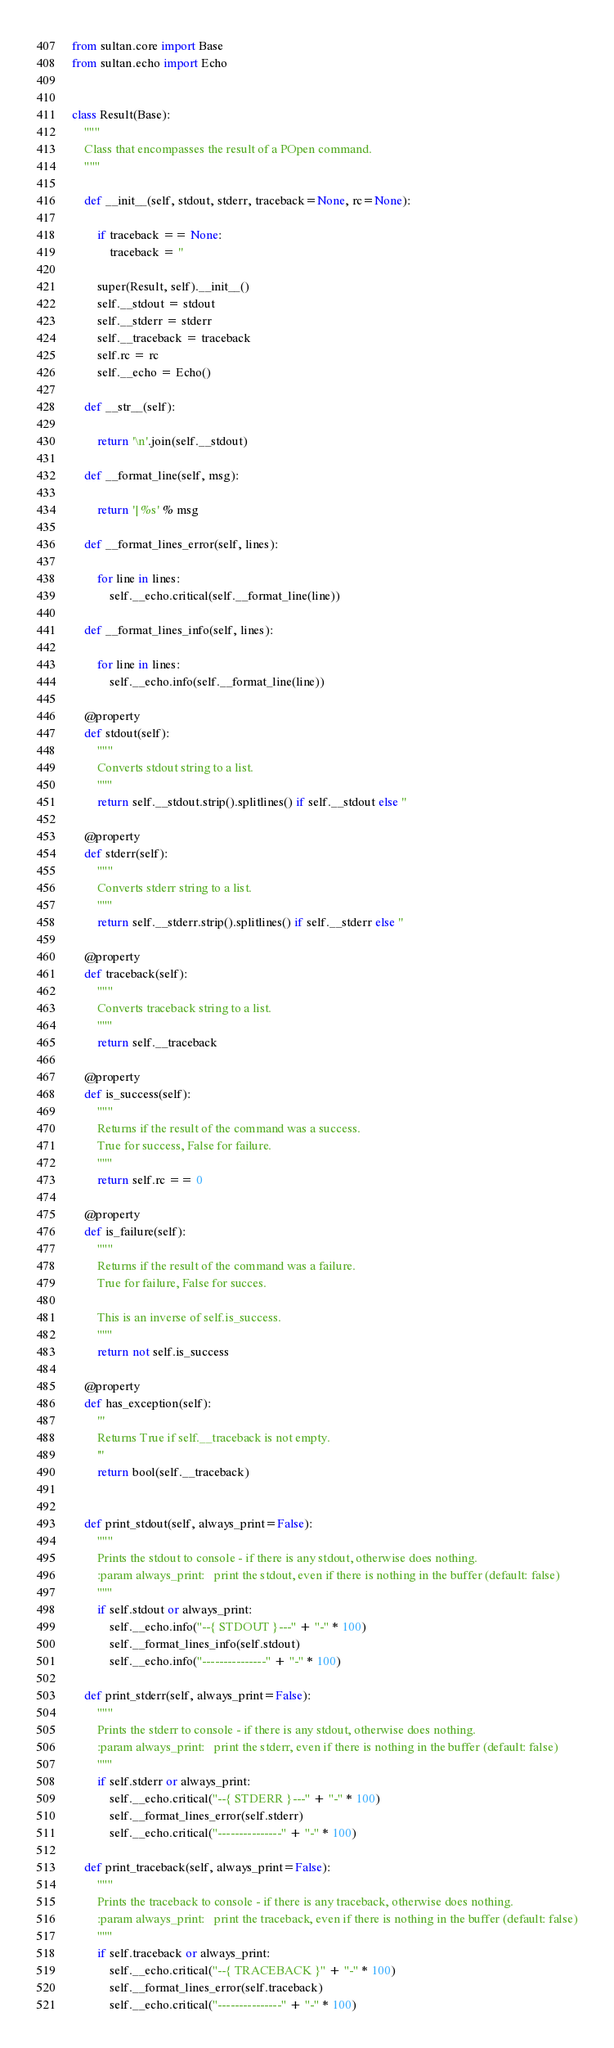Convert code to text. <code><loc_0><loc_0><loc_500><loc_500><_Python_>from sultan.core import Base
from sultan.echo import Echo


class Result(Base):
    """
    Class that encompasses the result of a POpen command.
    """

    def __init__(self, stdout, stderr, traceback=None, rc=None):

        if traceback == None:
            traceback = ''

        super(Result, self).__init__()        
        self.__stdout = stdout
        self.__stderr = stderr
        self.__traceback = traceback
        self.rc = rc
        self.__echo = Echo()

    def __str__(self):

        return '\n'.join(self.__stdout)

    def __format_line(self, msg):

        return '| %s' % msg

    def __format_lines_error(self, lines):

        for line in lines:
            self.__echo.critical(self.__format_line(line))

    def __format_lines_info(self, lines):

        for line in lines:
            self.__echo.info(self.__format_line(line))

    @property
    def stdout(self):
        """
        Converts stdout string to a list.
        """
        return self.__stdout.strip().splitlines() if self.__stdout else ''

    @property
    def stderr(self):
        """
        Converts stderr string to a list.
        """
        return self.__stderr.strip().splitlines() if self.__stderr else ''

    @property
    def traceback(self):
        """
        Converts traceback string to a list.
        """
        return self.__traceback

    @property
    def is_success(self):
        """
        Returns if the result of the command was a success.
        True for success, False for failure.
        """
        return self.rc == 0

    @property
    def is_failure(self):
        """
        Returns if the result of the command was a failure.
        True for failure, False for succes.

        This is an inverse of self.is_success.
        """
        return not self.is_success

    @property
    def has_exception(self):
        '''
        Returns True if self.__traceback is not empty.
        '''
        return bool(self.__traceback)


    def print_stdout(self, always_print=False):
        """
        Prints the stdout to console - if there is any stdout, otherwise does nothing.
        :param always_print:   print the stdout, even if there is nothing in the buffer (default: false)
        """
        if self.stdout or always_print:
            self.__echo.info("--{ STDOUT }---" + "-" * 100)
            self.__format_lines_info(self.stdout)
            self.__echo.info("---------------" + "-" * 100)

    def print_stderr(self, always_print=False):
        """
        Prints the stderr to console - if there is any stdout, otherwise does nothing.
        :param always_print:   print the stderr, even if there is nothing in the buffer (default: false)
        """
        if self.stderr or always_print:
            self.__echo.critical("--{ STDERR }---" + "-" * 100)
            self.__format_lines_error(self.stderr)
            self.__echo.critical("---------------" + "-" * 100)

    def print_traceback(self, always_print=False):
        """
        Prints the traceback to console - if there is any traceback, otherwise does nothing.
        :param always_print:   print the traceback, even if there is nothing in the buffer (default: false)
        """
        if self.traceback or always_print:
            self.__echo.critical("--{ TRACEBACK }" + "-" * 100)
            self.__format_lines_error(self.traceback)
            self.__echo.critical("---------------" + "-" * 100)


</code> 